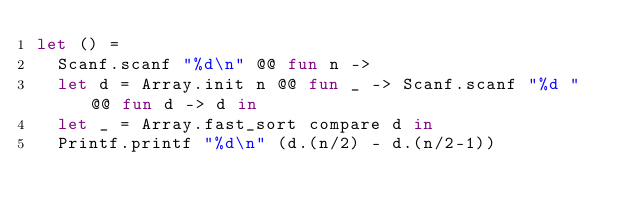<code> <loc_0><loc_0><loc_500><loc_500><_OCaml_>let () =
  Scanf.scanf "%d\n" @@ fun n ->
  let d = Array.init n @@ fun _ -> Scanf.scanf "%d " @@ fun d -> d in
  let _ = Array.fast_sort compare d in
  Printf.printf "%d\n" (d.(n/2) - d.(n/2-1))</code> 